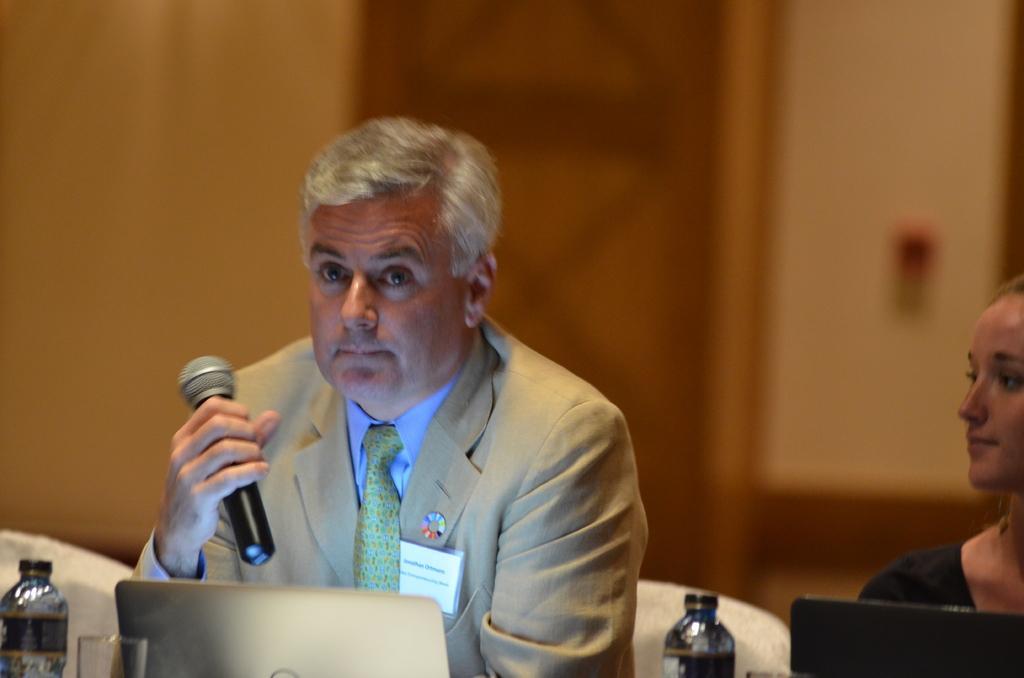Describe this image in one or two sentences. In the foreground of the picture there are laptops, bottles, glass, man holding a mic and a woman. In the foreground there are chairs also. The background is blurred. In the background there are door and wall. 